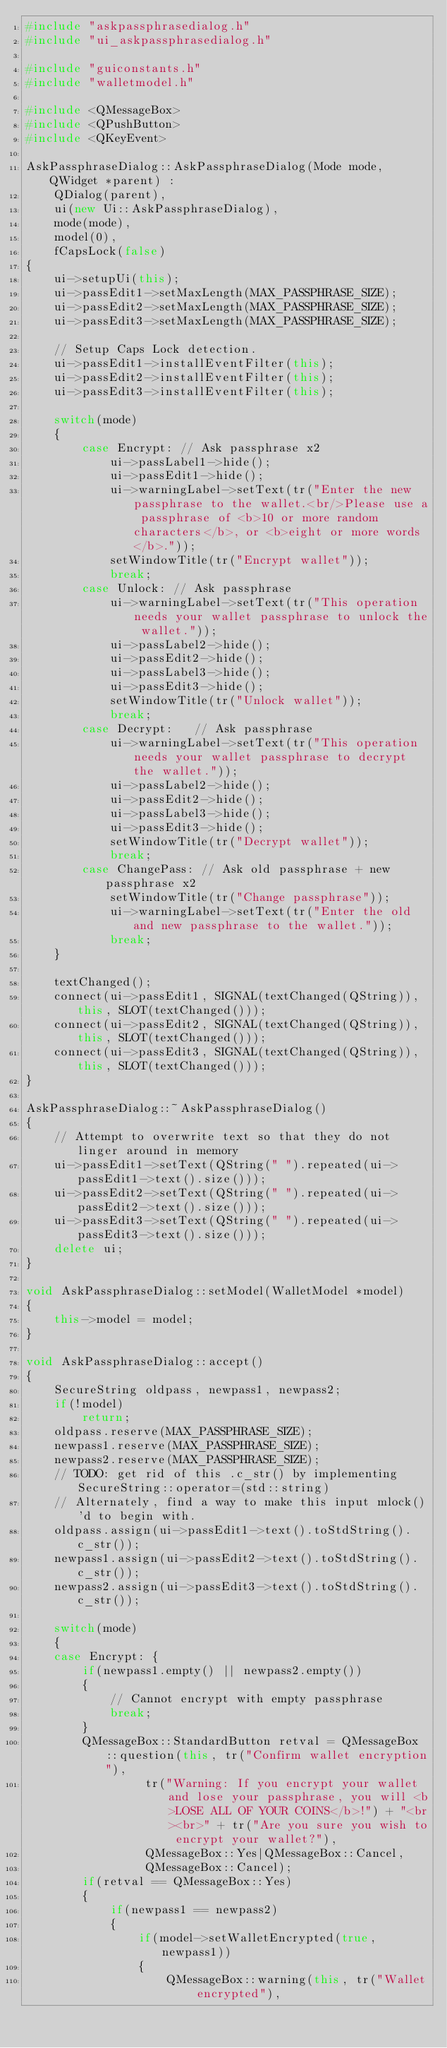<code> <loc_0><loc_0><loc_500><loc_500><_C++_>#include "askpassphrasedialog.h"
#include "ui_askpassphrasedialog.h"

#include "guiconstants.h"
#include "walletmodel.h"

#include <QMessageBox>
#include <QPushButton>
#include <QKeyEvent>

AskPassphraseDialog::AskPassphraseDialog(Mode mode, QWidget *parent) :
    QDialog(parent),
    ui(new Ui::AskPassphraseDialog),
    mode(mode),
    model(0),
    fCapsLock(false)
{
    ui->setupUi(this);
    ui->passEdit1->setMaxLength(MAX_PASSPHRASE_SIZE);
    ui->passEdit2->setMaxLength(MAX_PASSPHRASE_SIZE);
    ui->passEdit3->setMaxLength(MAX_PASSPHRASE_SIZE);
    
    // Setup Caps Lock detection.
    ui->passEdit1->installEventFilter(this);
    ui->passEdit2->installEventFilter(this);
    ui->passEdit3->installEventFilter(this);

    switch(mode)
    {
        case Encrypt: // Ask passphrase x2
            ui->passLabel1->hide();
            ui->passEdit1->hide();
            ui->warningLabel->setText(tr("Enter the new passphrase to the wallet.<br/>Please use a passphrase of <b>10 or more random characters</b>, or <b>eight or more words</b>."));
            setWindowTitle(tr("Encrypt wallet"));
            break;
        case Unlock: // Ask passphrase
            ui->warningLabel->setText(tr("This operation needs your wallet passphrase to unlock the wallet."));
            ui->passLabel2->hide();
            ui->passEdit2->hide();
            ui->passLabel3->hide();
            ui->passEdit3->hide();
            setWindowTitle(tr("Unlock wallet"));
            break;
        case Decrypt:   // Ask passphrase
            ui->warningLabel->setText(tr("This operation needs your wallet passphrase to decrypt the wallet."));
            ui->passLabel2->hide();
            ui->passEdit2->hide();
            ui->passLabel3->hide();
            ui->passEdit3->hide();
            setWindowTitle(tr("Decrypt wallet"));
            break;
        case ChangePass: // Ask old passphrase + new passphrase x2
            setWindowTitle(tr("Change passphrase"));
            ui->warningLabel->setText(tr("Enter the old and new passphrase to the wallet."));
            break;
    }

    textChanged();
    connect(ui->passEdit1, SIGNAL(textChanged(QString)), this, SLOT(textChanged()));
    connect(ui->passEdit2, SIGNAL(textChanged(QString)), this, SLOT(textChanged()));
    connect(ui->passEdit3, SIGNAL(textChanged(QString)), this, SLOT(textChanged()));
}

AskPassphraseDialog::~AskPassphraseDialog()
{
    // Attempt to overwrite text so that they do not linger around in memory
    ui->passEdit1->setText(QString(" ").repeated(ui->passEdit1->text().size()));
    ui->passEdit2->setText(QString(" ").repeated(ui->passEdit2->text().size()));
    ui->passEdit3->setText(QString(" ").repeated(ui->passEdit3->text().size()));
    delete ui;
}

void AskPassphraseDialog::setModel(WalletModel *model)
{
    this->model = model;
}

void AskPassphraseDialog::accept()
{
    SecureString oldpass, newpass1, newpass2;
    if(!model)
        return;
    oldpass.reserve(MAX_PASSPHRASE_SIZE);
    newpass1.reserve(MAX_PASSPHRASE_SIZE);
    newpass2.reserve(MAX_PASSPHRASE_SIZE);
    // TODO: get rid of this .c_str() by implementing SecureString::operator=(std::string)
    // Alternately, find a way to make this input mlock()'d to begin with.
    oldpass.assign(ui->passEdit1->text().toStdString().c_str());
    newpass1.assign(ui->passEdit2->text().toStdString().c_str());
    newpass2.assign(ui->passEdit3->text().toStdString().c_str());

    switch(mode)
    {
    case Encrypt: {
        if(newpass1.empty() || newpass2.empty())
        {
            // Cannot encrypt with empty passphrase
            break;
        }
        QMessageBox::StandardButton retval = QMessageBox::question(this, tr("Confirm wallet encryption"),
                 tr("Warning: If you encrypt your wallet and lose your passphrase, you will <b>LOSE ALL OF YOUR COINS</b>!") + "<br><br>" + tr("Are you sure you wish to encrypt your wallet?"),
                 QMessageBox::Yes|QMessageBox::Cancel,
                 QMessageBox::Cancel);
        if(retval == QMessageBox::Yes)
        {
            if(newpass1 == newpass2)
            {
                if(model->setWalletEncrypted(true, newpass1))
                {
                    QMessageBox::warning(this, tr("Wallet encrypted"),</code> 